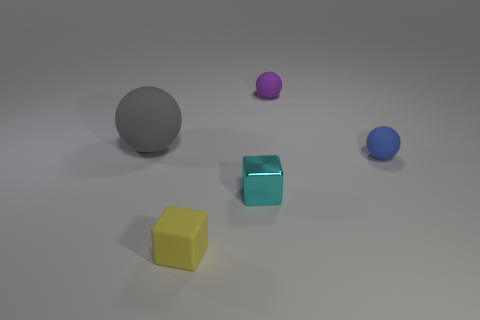Does the matte ball that is right of the purple matte sphere have the same color as the cube that is in front of the shiny block?
Your answer should be very brief. No. Is the number of big matte spheres on the right side of the small blue sphere greater than the number of tiny cyan cubes?
Provide a succinct answer. No. What material is the big sphere?
Ensure brevity in your answer.  Rubber. There is a yellow object that is made of the same material as the blue thing; what shape is it?
Keep it short and to the point. Cube. What size is the ball that is in front of the sphere left of the cyan block?
Provide a short and direct response. Small. There is a tiny matte thing behind the large thing; what color is it?
Your answer should be compact. Purple. Are there any cyan shiny things of the same shape as the purple object?
Give a very brief answer. No. Are there fewer blue matte things behind the small metallic thing than tiny rubber blocks that are in front of the small purple object?
Ensure brevity in your answer.  No. The metallic thing is what color?
Make the answer very short. Cyan. There is a tiny cube that is behind the yellow rubber block; is there a object that is behind it?
Give a very brief answer. Yes. 